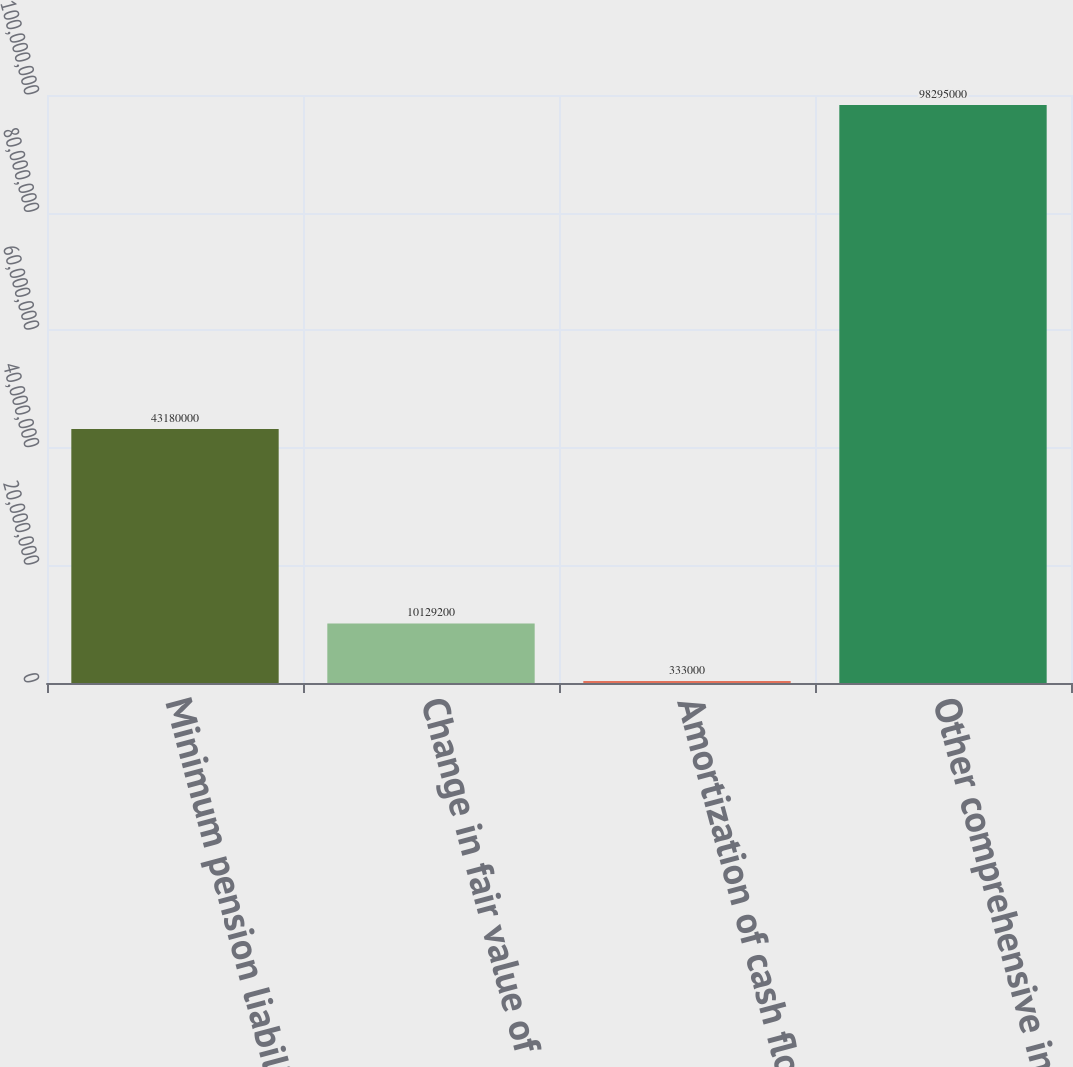Convert chart. <chart><loc_0><loc_0><loc_500><loc_500><bar_chart><fcel>Minimum pension liability<fcel>Change in fair value of<fcel>Amortization of cash flow<fcel>Other comprehensive income<nl><fcel>4.318e+07<fcel>1.01292e+07<fcel>333000<fcel>9.8295e+07<nl></chart> 